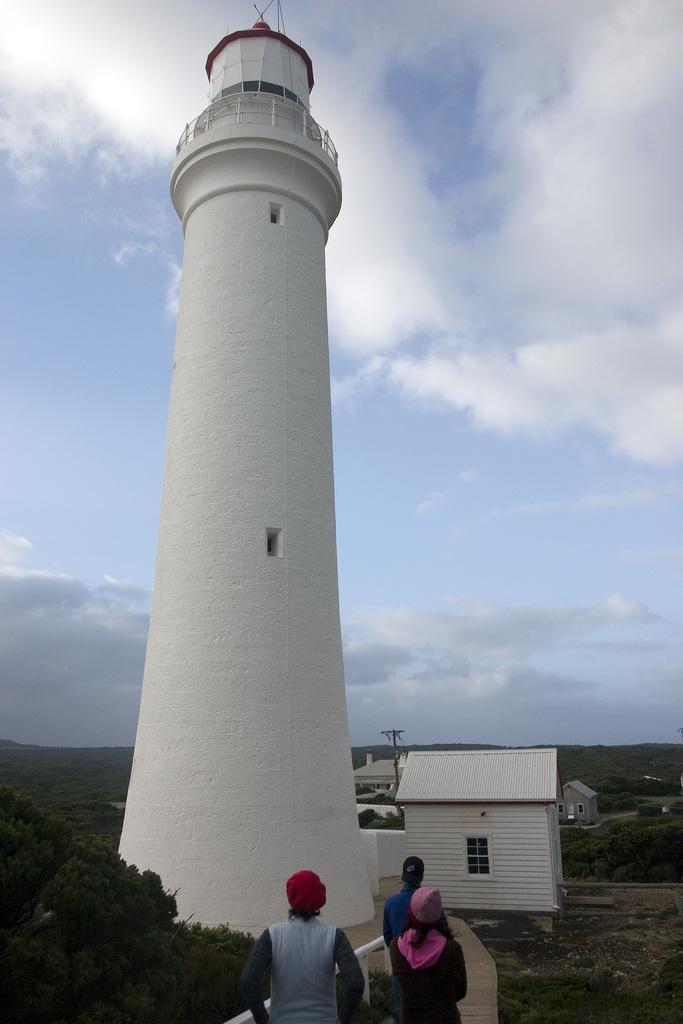Please provide a concise description of this image. In this image I can see the ground, the path, few persons standing on the path, the railing, few trees, a huge white colored tower and a white colored house. In the background I can see few sheds, few trees, a pole and the sky. 